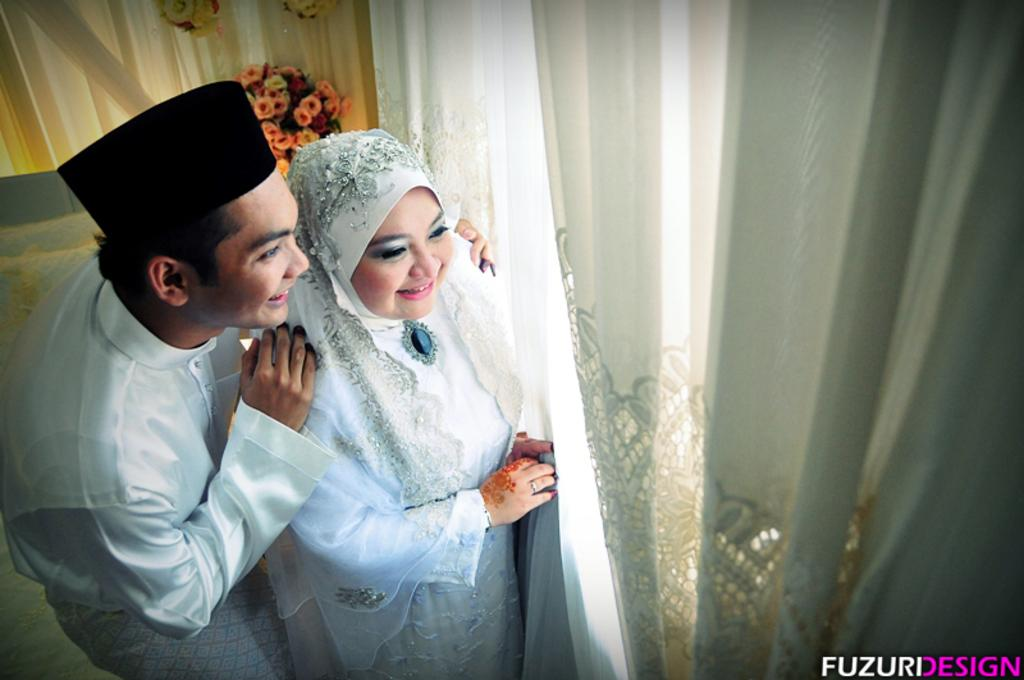How many people are in the image? There are two people in the image, a boy and a girl. Where are the boy and girl located in the image? They are on the left side of the image. What is behind the boy and girl? They are in front of a curtain. What can be seen in the background of the image? There are flowers and curtains in the background of the image. What type of cakes are being served by the stream in the image? There is no stream or cakes present in the image. 